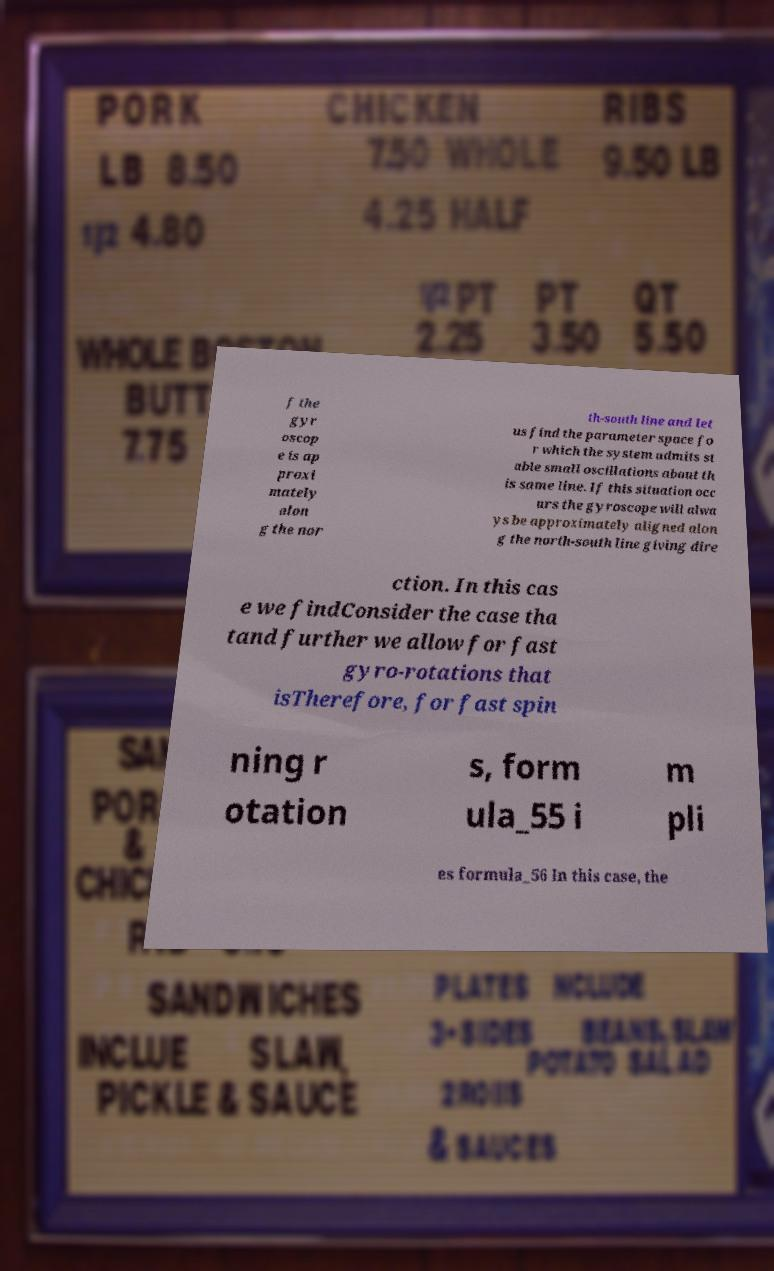Please identify and transcribe the text found in this image. f the gyr oscop e is ap proxi mately alon g the nor th-south line and let us find the parameter space fo r which the system admits st able small oscillations about th is same line. If this situation occ urs the gyroscope will alwa ys be approximately aligned alon g the north-south line giving dire ction. In this cas e we findConsider the case tha tand further we allow for fast gyro-rotations that isTherefore, for fast spin ning r otation s, form ula_55 i m pli es formula_56 In this case, the 